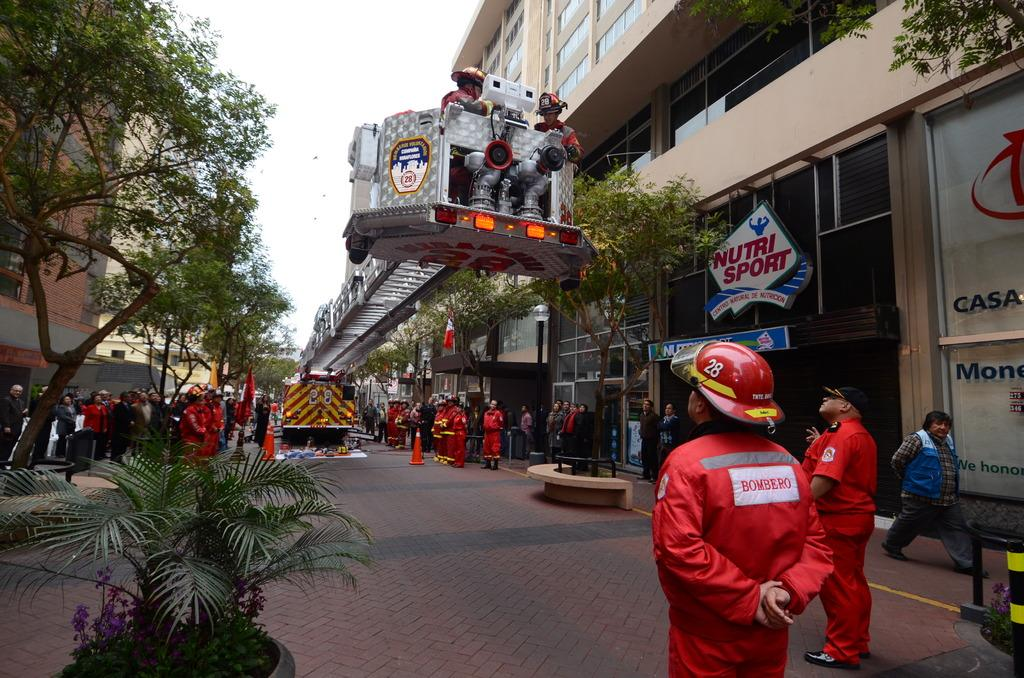What is happening on the road in the image? There are many persons standing on the road in the image. What are the persons wearing? The persons are wearing uniforms. What can be seen at the bottom of the image? There is ground visible at the bottom of the image. What is located to the left of the image? There is a tree to the left of the image. What is located to the right of the image? There are buildings to the right of the image. Where is the sofa placed in the image? There is no sofa present in the image. What type of ticket can be seen in the hands of the persons in the image? There is no ticket visible in the hands of the persons in the image. 